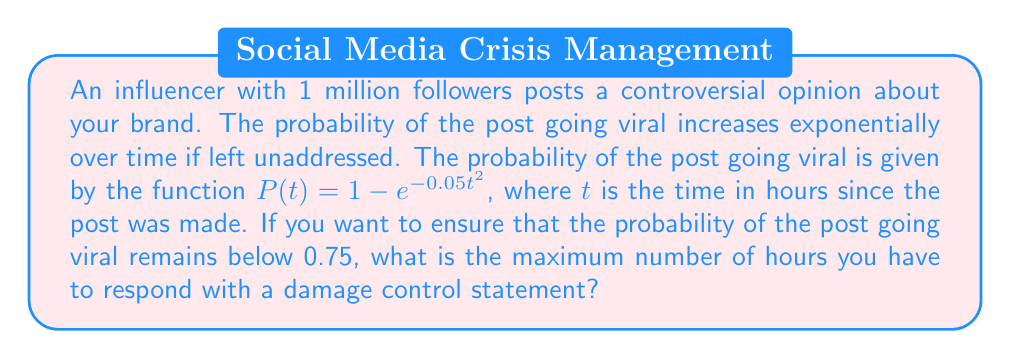Give your solution to this math problem. To solve this problem, we need to follow these steps:

1. Understand the given function:
   $P(t) = 1 - e^{-0.05t^2}$
   This function represents the probability of the post going viral as a function of time.

2. Set up the inequality:
   We want the probability to remain below 0.75, so:
   $P(t) < 0.75$

3. Substitute the function into the inequality:
   $1 - e^{-0.05t^2} < 0.75$

4. Solve the inequality:
   $e^{-0.05t^2} > 0.25$
   
   Taking the natural log of both sides:
   $\ln(e^{-0.05t^2}) > \ln(0.25)$
   
   Simplify:
   $-0.05t^2 > \ln(0.25)$
   
   Divide both sides by -0.05:
   $t^2 < -\frac{\ln(0.25)}{0.05}$
   
   Take the square root of both sides:
   $t < \sqrt{-\frac{\ln(0.25)}{0.05}}$

5. Calculate the result:
   $t < \sqrt{-\frac{\ln(0.25)}{0.05}} \approx 5.9915$

6. Since we need the maximum number of whole hours, we round down to the nearest integer.
Answer: The maximum number of hours to respond with a damage control statement is 5 hours. 